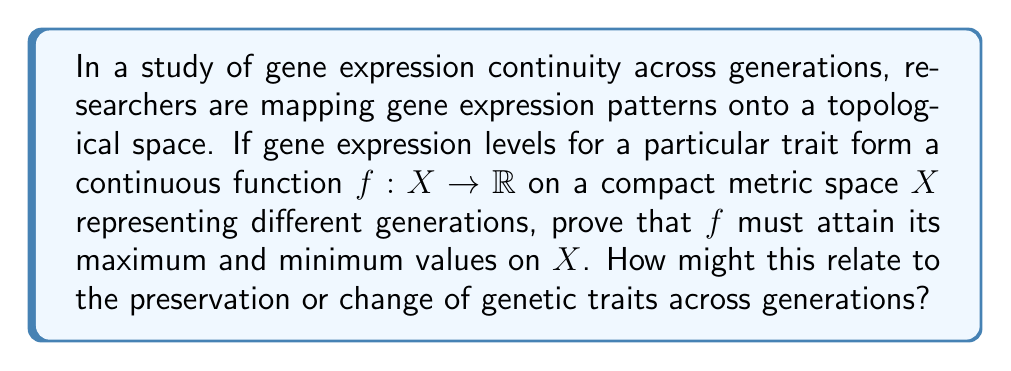What is the answer to this math problem? To prove that the continuous function $f: X \rightarrow \mathbb{R}$ attains its maximum and minimum values on the compact metric space $X$, we can use the Extreme Value Theorem. This proof relates to the continuity of gene expression patterns across generations as follows:

1. First, recall the Extreme Value Theorem: If $f$ is a continuous real-valued function on a compact metric space $X$, then $f$ attains its maximum and minimum values on $X$.

2. We are given that $X$ is a compact metric space representing different generations, and $f$ is a continuous function mapping gene expression levels to real numbers.

3. To prove $f$ attains its maximum:
   a. Let $S = \{f(x) : x \in X\}$ be the set of all function values.
   b. Since $X$ is compact and $f$ is continuous, $S$ is bounded above. Let $M = \sup S$.
   c. For each $n \in \mathbb{N}$, there exists $x_n \in X$ such that $M - \frac{1}{n} < f(x_n) \leq M$.
   d. The sequence $(x_n)$ has a convergent subsequence $(x_{n_k})$ because $X$ is compact.
   e. Let $x_{n_k} \rightarrow x^* \in X$ as $k \rightarrow \infty$.
   f. By continuity of $f$, $f(x_{n_k}) \rightarrow f(x^*)$ as $k \rightarrow \infty$.
   g. Therefore, $f(x^*) = M$, so $f$ attains its maximum at $x^*$.

4. The proof for the minimum follows similarly.

5. In the context of gene expression across generations:
   - The compact metric space $X$ represents a continuum of generations.
   - The continuity of $f$ implies that gene expression levels change gradually across generations.
   - The existence of maximum and minimum values suggests that there are upper and lower bounds on gene expression levels for the studied trait.
   - These bounds may represent the limits of genetic variation for the trait within the population over generations.

This result implies that even as genetic traits may change across generations, there are limits to how much they can vary, which is consistent with the idea of genetic continuity and constraints in evolution.
Answer: The function $f$ attains its maximum and minimum values on $X$ by the Extreme Value Theorem. This implies that gene expression levels for the studied trait have upper and lower bounds across generations, suggesting limits to genetic variation while allowing for gradual changes over time. 